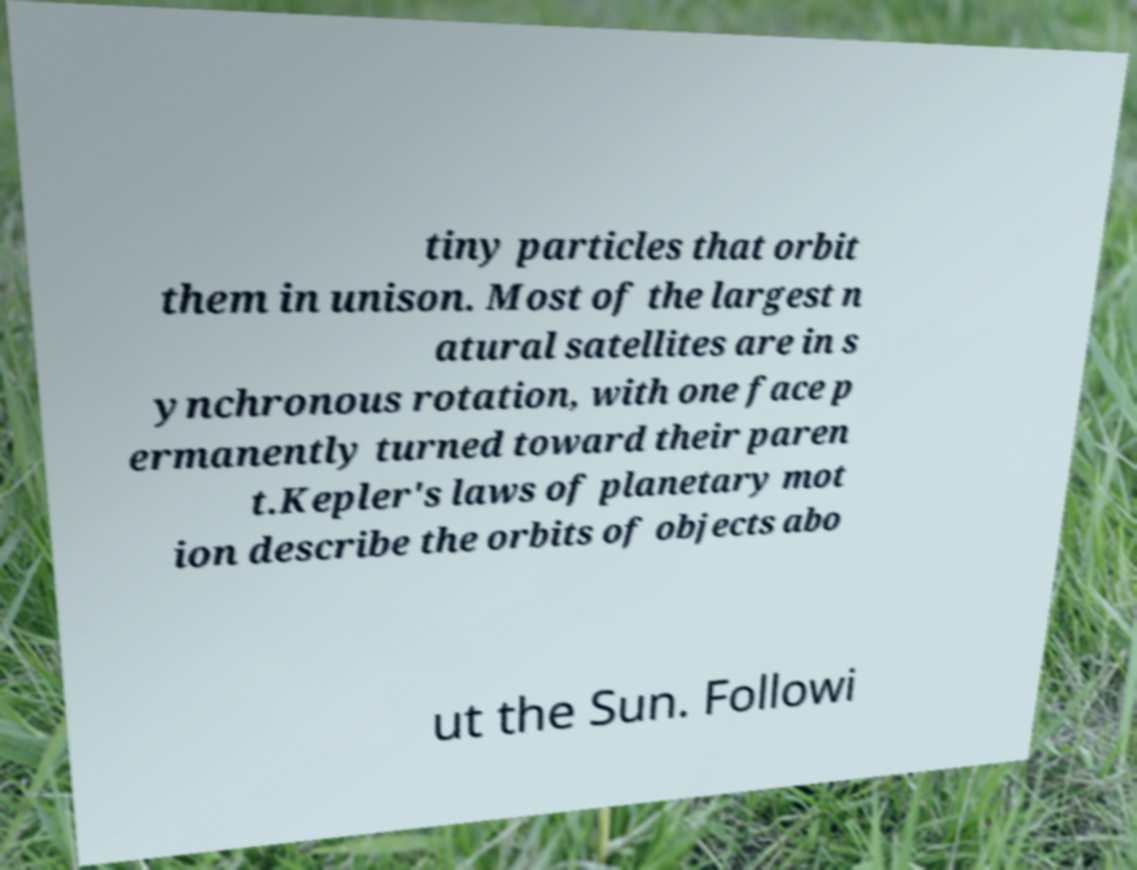For documentation purposes, I need the text within this image transcribed. Could you provide that? tiny particles that orbit them in unison. Most of the largest n atural satellites are in s ynchronous rotation, with one face p ermanently turned toward their paren t.Kepler's laws of planetary mot ion describe the orbits of objects abo ut the Sun. Followi 